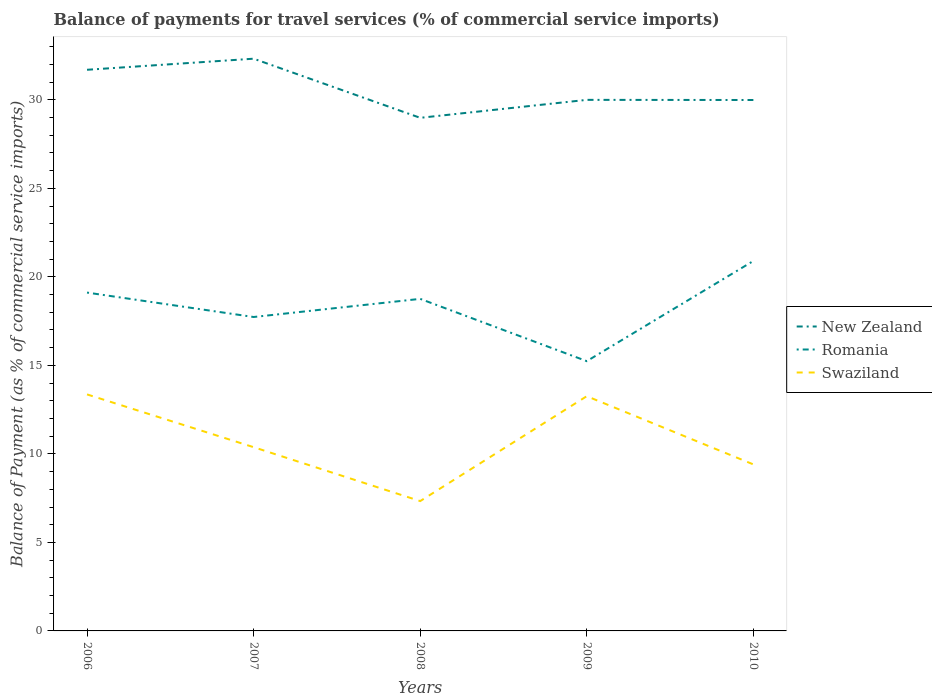How many different coloured lines are there?
Your answer should be very brief. 3. Does the line corresponding to Romania intersect with the line corresponding to Swaziland?
Offer a very short reply. No. Is the number of lines equal to the number of legend labels?
Keep it short and to the point. Yes. Across all years, what is the maximum balance of payments for travel services in Swaziland?
Provide a succinct answer. 7.34. What is the total balance of payments for travel services in Swaziland in the graph?
Offer a terse response. 3.04. What is the difference between the highest and the second highest balance of payments for travel services in New Zealand?
Provide a short and direct response. 3.34. What is the difference between the highest and the lowest balance of payments for travel services in Romania?
Your response must be concise. 3. Is the balance of payments for travel services in Swaziland strictly greater than the balance of payments for travel services in Romania over the years?
Your answer should be compact. Yes. How many lines are there?
Your answer should be very brief. 3. How many years are there in the graph?
Give a very brief answer. 5. Are the values on the major ticks of Y-axis written in scientific E-notation?
Offer a terse response. No. Does the graph contain any zero values?
Keep it short and to the point. No. Where does the legend appear in the graph?
Provide a short and direct response. Center right. What is the title of the graph?
Provide a short and direct response. Balance of payments for travel services (% of commercial service imports). What is the label or title of the X-axis?
Offer a very short reply. Years. What is the label or title of the Y-axis?
Your response must be concise. Balance of Payment (as % of commercial service imports). What is the Balance of Payment (as % of commercial service imports) in New Zealand in 2006?
Give a very brief answer. 31.7. What is the Balance of Payment (as % of commercial service imports) of Romania in 2006?
Keep it short and to the point. 19.11. What is the Balance of Payment (as % of commercial service imports) of Swaziland in 2006?
Offer a very short reply. 13.36. What is the Balance of Payment (as % of commercial service imports) in New Zealand in 2007?
Offer a very short reply. 32.33. What is the Balance of Payment (as % of commercial service imports) in Romania in 2007?
Provide a short and direct response. 17.73. What is the Balance of Payment (as % of commercial service imports) in Swaziland in 2007?
Offer a terse response. 10.38. What is the Balance of Payment (as % of commercial service imports) in New Zealand in 2008?
Provide a short and direct response. 28.99. What is the Balance of Payment (as % of commercial service imports) of Romania in 2008?
Your answer should be compact. 18.76. What is the Balance of Payment (as % of commercial service imports) of Swaziland in 2008?
Make the answer very short. 7.34. What is the Balance of Payment (as % of commercial service imports) of New Zealand in 2009?
Make the answer very short. 30. What is the Balance of Payment (as % of commercial service imports) of Romania in 2009?
Your answer should be very brief. 15.24. What is the Balance of Payment (as % of commercial service imports) of Swaziland in 2009?
Your answer should be compact. 13.26. What is the Balance of Payment (as % of commercial service imports) in New Zealand in 2010?
Make the answer very short. 29.99. What is the Balance of Payment (as % of commercial service imports) in Romania in 2010?
Provide a succinct answer. 20.9. What is the Balance of Payment (as % of commercial service imports) in Swaziland in 2010?
Your answer should be compact. 9.41. Across all years, what is the maximum Balance of Payment (as % of commercial service imports) in New Zealand?
Provide a succinct answer. 32.33. Across all years, what is the maximum Balance of Payment (as % of commercial service imports) of Romania?
Your response must be concise. 20.9. Across all years, what is the maximum Balance of Payment (as % of commercial service imports) of Swaziland?
Offer a terse response. 13.36. Across all years, what is the minimum Balance of Payment (as % of commercial service imports) in New Zealand?
Give a very brief answer. 28.99. Across all years, what is the minimum Balance of Payment (as % of commercial service imports) of Romania?
Provide a short and direct response. 15.24. Across all years, what is the minimum Balance of Payment (as % of commercial service imports) of Swaziland?
Give a very brief answer. 7.34. What is the total Balance of Payment (as % of commercial service imports) in New Zealand in the graph?
Provide a short and direct response. 153. What is the total Balance of Payment (as % of commercial service imports) in Romania in the graph?
Provide a succinct answer. 91.75. What is the total Balance of Payment (as % of commercial service imports) of Swaziland in the graph?
Make the answer very short. 53.74. What is the difference between the Balance of Payment (as % of commercial service imports) in New Zealand in 2006 and that in 2007?
Provide a succinct answer. -0.63. What is the difference between the Balance of Payment (as % of commercial service imports) in Romania in 2006 and that in 2007?
Your response must be concise. 1.38. What is the difference between the Balance of Payment (as % of commercial service imports) in Swaziland in 2006 and that in 2007?
Keep it short and to the point. 2.98. What is the difference between the Balance of Payment (as % of commercial service imports) in New Zealand in 2006 and that in 2008?
Offer a very short reply. 2.71. What is the difference between the Balance of Payment (as % of commercial service imports) of Romania in 2006 and that in 2008?
Offer a very short reply. 0.36. What is the difference between the Balance of Payment (as % of commercial service imports) of Swaziland in 2006 and that in 2008?
Give a very brief answer. 6.03. What is the difference between the Balance of Payment (as % of commercial service imports) of New Zealand in 2006 and that in 2009?
Give a very brief answer. 1.7. What is the difference between the Balance of Payment (as % of commercial service imports) of Romania in 2006 and that in 2009?
Offer a terse response. 3.87. What is the difference between the Balance of Payment (as % of commercial service imports) of Swaziland in 2006 and that in 2009?
Give a very brief answer. 0.1. What is the difference between the Balance of Payment (as % of commercial service imports) in New Zealand in 2006 and that in 2010?
Ensure brevity in your answer.  1.71. What is the difference between the Balance of Payment (as % of commercial service imports) of Romania in 2006 and that in 2010?
Ensure brevity in your answer.  -1.79. What is the difference between the Balance of Payment (as % of commercial service imports) in Swaziland in 2006 and that in 2010?
Make the answer very short. 3.95. What is the difference between the Balance of Payment (as % of commercial service imports) in New Zealand in 2007 and that in 2008?
Offer a terse response. 3.34. What is the difference between the Balance of Payment (as % of commercial service imports) in Romania in 2007 and that in 2008?
Make the answer very short. -1.02. What is the difference between the Balance of Payment (as % of commercial service imports) of Swaziland in 2007 and that in 2008?
Keep it short and to the point. 3.04. What is the difference between the Balance of Payment (as % of commercial service imports) in New Zealand in 2007 and that in 2009?
Make the answer very short. 2.33. What is the difference between the Balance of Payment (as % of commercial service imports) in Romania in 2007 and that in 2009?
Your answer should be compact. 2.49. What is the difference between the Balance of Payment (as % of commercial service imports) of Swaziland in 2007 and that in 2009?
Offer a terse response. -2.88. What is the difference between the Balance of Payment (as % of commercial service imports) of New Zealand in 2007 and that in 2010?
Offer a very short reply. 2.33. What is the difference between the Balance of Payment (as % of commercial service imports) in Romania in 2007 and that in 2010?
Your answer should be very brief. -3.17. What is the difference between the Balance of Payment (as % of commercial service imports) in Swaziland in 2007 and that in 2010?
Your response must be concise. 0.97. What is the difference between the Balance of Payment (as % of commercial service imports) of New Zealand in 2008 and that in 2009?
Make the answer very short. -1.01. What is the difference between the Balance of Payment (as % of commercial service imports) of Romania in 2008 and that in 2009?
Keep it short and to the point. 3.52. What is the difference between the Balance of Payment (as % of commercial service imports) of Swaziland in 2008 and that in 2009?
Your answer should be very brief. -5.92. What is the difference between the Balance of Payment (as % of commercial service imports) in New Zealand in 2008 and that in 2010?
Your answer should be compact. -1.01. What is the difference between the Balance of Payment (as % of commercial service imports) of Romania in 2008 and that in 2010?
Provide a short and direct response. -2.14. What is the difference between the Balance of Payment (as % of commercial service imports) of Swaziland in 2008 and that in 2010?
Provide a succinct answer. -2.07. What is the difference between the Balance of Payment (as % of commercial service imports) in New Zealand in 2009 and that in 2010?
Make the answer very short. 0.01. What is the difference between the Balance of Payment (as % of commercial service imports) of Romania in 2009 and that in 2010?
Make the answer very short. -5.66. What is the difference between the Balance of Payment (as % of commercial service imports) of Swaziland in 2009 and that in 2010?
Offer a very short reply. 3.85. What is the difference between the Balance of Payment (as % of commercial service imports) in New Zealand in 2006 and the Balance of Payment (as % of commercial service imports) in Romania in 2007?
Make the answer very short. 13.97. What is the difference between the Balance of Payment (as % of commercial service imports) in New Zealand in 2006 and the Balance of Payment (as % of commercial service imports) in Swaziland in 2007?
Your answer should be compact. 21.32. What is the difference between the Balance of Payment (as % of commercial service imports) of Romania in 2006 and the Balance of Payment (as % of commercial service imports) of Swaziland in 2007?
Provide a succinct answer. 8.73. What is the difference between the Balance of Payment (as % of commercial service imports) of New Zealand in 2006 and the Balance of Payment (as % of commercial service imports) of Romania in 2008?
Ensure brevity in your answer.  12.94. What is the difference between the Balance of Payment (as % of commercial service imports) of New Zealand in 2006 and the Balance of Payment (as % of commercial service imports) of Swaziland in 2008?
Offer a terse response. 24.36. What is the difference between the Balance of Payment (as % of commercial service imports) of Romania in 2006 and the Balance of Payment (as % of commercial service imports) of Swaziland in 2008?
Your answer should be compact. 11.78. What is the difference between the Balance of Payment (as % of commercial service imports) in New Zealand in 2006 and the Balance of Payment (as % of commercial service imports) in Romania in 2009?
Your response must be concise. 16.46. What is the difference between the Balance of Payment (as % of commercial service imports) of New Zealand in 2006 and the Balance of Payment (as % of commercial service imports) of Swaziland in 2009?
Offer a very short reply. 18.44. What is the difference between the Balance of Payment (as % of commercial service imports) in Romania in 2006 and the Balance of Payment (as % of commercial service imports) in Swaziland in 2009?
Offer a terse response. 5.85. What is the difference between the Balance of Payment (as % of commercial service imports) in New Zealand in 2006 and the Balance of Payment (as % of commercial service imports) in Romania in 2010?
Your response must be concise. 10.8. What is the difference between the Balance of Payment (as % of commercial service imports) in New Zealand in 2006 and the Balance of Payment (as % of commercial service imports) in Swaziland in 2010?
Your answer should be very brief. 22.29. What is the difference between the Balance of Payment (as % of commercial service imports) in Romania in 2006 and the Balance of Payment (as % of commercial service imports) in Swaziland in 2010?
Provide a short and direct response. 9.71. What is the difference between the Balance of Payment (as % of commercial service imports) of New Zealand in 2007 and the Balance of Payment (as % of commercial service imports) of Romania in 2008?
Give a very brief answer. 13.57. What is the difference between the Balance of Payment (as % of commercial service imports) of New Zealand in 2007 and the Balance of Payment (as % of commercial service imports) of Swaziland in 2008?
Keep it short and to the point. 24.99. What is the difference between the Balance of Payment (as % of commercial service imports) of Romania in 2007 and the Balance of Payment (as % of commercial service imports) of Swaziland in 2008?
Your answer should be very brief. 10.4. What is the difference between the Balance of Payment (as % of commercial service imports) of New Zealand in 2007 and the Balance of Payment (as % of commercial service imports) of Romania in 2009?
Offer a very short reply. 17.09. What is the difference between the Balance of Payment (as % of commercial service imports) of New Zealand in 2007 and the Balance of Payment (as % of commercial service imports) of Swaziland in 2009?
Provide a succinct answer. 19.07. What is the difference between the Balance of Payment (as % of commercial service imports) of Romania in 2007 and the Balance of Payment (as % of commercial service imports) of Swaziland in 2009?
Make the answer very short. 4.47. What is the difference between the Balance of Payment (as % of commercial service imports) in New Zealand in 2007 and the Balance of Payment (as % of commercial service imports) in Romania in 2010?
Provide a succinct answer. 11.43. What is the difference between the Balance of Payment (as % of commercial service imports) in New Zealand in 2007 and the Balance of Payment (as % of commercial service imports) in Swaziland in 2010?
Your response must be concise. 22.92. What is the difference between the Balance of Payment (as % of commercial service imports) in Romania in 2007 and the Balance of Payment (as % of commercial service imports) in Swaziland in 2010?
Make the answer very short. 8.33. What is the difference between the Balance of Payment (as % of commercial service imports) in New Zealand in 2008 and the Balance of Payment (as % of commercial service imports) in Romania in 2009?
Your answer should be compact. 13.75. What is the difference between the Balance of Payment (as % of commercial service imports) of New Zealand in 2008 and the Balance of Payment (as % of commercial service imports) of Swaziland in 2009?
Give a very brief answer. 15.73. What is the difference between the Balance of Payment (as % of commercial service imports) in Romania in 2008 and the Balance of Payment (as % of commercial service imports) in Swaziland in 2009?
Your answer should be compact. 5.5. What is the difference between the Balance of Payment (as % of commercial service imports) of New Zealand in 2008 and the Balance of Payment (as % of commercial service imports) of Romania in 2010?
Your answer should be very brief. 8.09. What is the difference between the Balance of Payment (as % of commercial service imports) in New Zealand in 2008 and the Balance of Payment (as % of commercial service imports) in Swaziland in 2010?
Your answer should be very brief. 19.58. What is the difference between the Balance of Payment (as % of commercial service imports) in Romania in 2008 and the Balance of Payment (as % of commercial service imports) in Swaziland in 2010?
Offer a terse response. 9.35. What is the difference between the Balance of Payment (as % of commercial service imports) in New Zealand in 2009 and the Balance of Payment (as % of commercial service imports) in Romania in 2010?
Make the answer very short. 9.1. What is the difference between the Balance of Payment (as % of commercial service imports) of New Zealand in 2009 and the Balance of Payment (as % of commercial service imports) of Swaziland in 2010?
Give a very brief answer. 20.59. What is the difference between the Balance of Payment (as % of commercial service imports) in Romania in 2009 and the Balance of Payment (as % of commercial service imports) in Swaziland in 2010?
Your answer should be compact. 5.83. What is the average Balance of Payment (as % of commercial service imports) of New Zealand per year?
Make the answer very short. 30.6. What is the average Balance of Payment (as % of commercial service imports) in Romania per year?
Offer a very short reply. 18.35. What is the average Balance of Payment (as % of commercial service imports) in Swaziland per year?
Your answer should be compact. 10.75. In the year 2006, what is the difference between the Balance of Payment (as % of commercial service imports) in New Zealand and Balance of Payment (as % of commercial service imports) in Romania?
Give a very brief answer. 12.59. In the year 2006, what is the difference between the Balance of Payment (as % of commercial service imports) in New Zealand and Balance of Payment (as % of commercial service imports) in Swaziland?
Your answer should be compact. 18.34. In the year 2006, what is the difference between the Balance of Payment (as % of commercial service imports) in Romania and Balance of Payment (as % of commercial service imports) in Swaziland?
Your answer should be compact. 5.75. In the year 2007, what is the difference between the Balance of Payment (as % of commercial service imports) of New Zealand and Balance of Payment (as % of commercial service imports) of Romania?
Provide a succinct answer. 14.59. In the year 2007, what is the difference between the Balance of Payment (as % of commercial service imports) of New Zealand and Balance of Payment (as % of commercial service imports) of Swaziland?
Give a very brief answer. 21.95. In the year 2007, what is the difference between the Balance of Payment (as % of commercial service imports) in Romania and Balance of Payment (as % of commercial service imports) in Swaziland?
Your answer should be compact. 7.35. In the year 2008, what is the difference between the Balance of Payment (as % of commercial service imports) of New Zealand and Balance of Payment (as % of commercial service imports) of Romania?
Your response must be concise. 10.23. In the year 2008, what is the difference between the Balance of Payment (as % of commercial service imports) of New Zealand and Balance of Payment (as % of commercial service imports) of Swaziland?
Offer a very short reply. 21.65. In the year 2008, what is the difference between the Balance of Payment (as % of commercial service imports) in Romania and Balance of Payment (as % of commercial service imports) in Swaziland?
Your answer should be compact. 11.42. In the year 2009, what is the difference between the Balance of Payment (as % of commercial service imports) of New Zealand and Balance of Payment (as % of commercial service imports) of Romania?
Ensure brevity in your answer.  14.76. In the year 2009, what is the difference between the Balance of Payment (as % of commercial service imports) in New Zealand and Balance of Payment (as % of commercial service imports) in Swaziland?
Your response must be concise. 16.74. In the year 2009, what is the difference between the Balance of Payment (as % of commercial service imports) in Romania and Balance of Payment (as % of commercial service imports) in Swaziland?
Offer a very short reply. 1.98. In the year 2010, what is the difference between the Balance of Payment (as % of commercial service imports) in New Zealand and Balance of Payment (as % of commercial service imports) in Romania?
Provide a short and direct response. 9.09. In the year 2010, what is the difference between the Balance of Payment (as % of commercial service imports) of New Zealand and Balance of Payment (as % of commercial service imports) of Swaziland?
Provide a short and direct response. 20.59. In the year 2010, what is the difference between the Balance of Payment (as % of commercial service imports) of Romania and Balance of Payment (as % of commercial service imports) of Swaziland?
Offer a very short reply. 11.49. What is the ratio of the Balance of Payment (as % of commercial service imports) of New Zealand in 2006 to that in 2007?
Provide a short and direct response. 0.98. What is the ratio of the Balance of Payment (as % of commercial service imports) in Romania in 2006 to that in 2007?
Ensure brevity in your answer.  1.08. What is the ratio of the Balance of Payment (as % of commercial service imports) of Swaziland in 2006 to that in 2007?
Offer a terse response. 1.29. What is the ratio of the Balance of Payment (as % of commercial service imports) of New Zealand in 2006 to that in 2008?
Your answer should be very brief. 1.09. What is the ratio of the Balance of Payment (as % of commercial service imports) of Romania in 2006 to that in 2008?
Offer a terse response. 1.02. What is the ratio of the Balance of Payment (as % of commercial service imports) in Swaziland in 2006 to that in 2008?
Provide a succinct answer. 1.82. What is the ratio of the Balance of Payment (as % of commercial service imports) in New Zealand in 2006 to that in 2009?
Offer a terse response. 1.06. What is the ratio of the Balance of Payment (as % of commercial service imports) of Romania in 2006 to that in 2009?
Offer a terse response. 1.25. What is the ratio of the Balance of Payment (as % of commercial service imports) of Swaziland in 2006 to that in 2009?
Provide a succinct answer. 1.01. What is the ratio of the Balance of Payment (as % of commercial service imports) of New Zealand in 2006 to that in 2010?
Your answer should be compact. 1.06. What is the ratio of the Balance of Payment (as % of commercial service imports) of Romania in 2006 to that in 2010?
Your answer should be very brief. 0.91. What is the ratio of the Balance of Payment (as % of commercial service imports) in Swaziland in 2006 to that in 2010?
Your answer should be compact. 1.42. What is the ratio of the Balance of Payment (as % of commercial service imports) of New Zealand in 2007 to that in 2008?
Offer a very short reply. 1.12. What is the ratio of the Balance of Payment (as % of commercial service imports) of Romania in 2007 to that in 2008?
Offer a very short reply. 0.95. What is the ratio of the Balance of Payment (as % of commercial service imports) in Swaziland in 2007 to that in 2008?
Your response must be concise. 1.42. What is the ratio of the Balance of Payment (as % of commercial service imports) of New Zealand in 2007 to that in 2009?
Provide a short and direct response. 1.08. What is the ratio of the Balance of Payment (as % of commercial service imports) of Romania in 2007 to that in 2009?
Your response must be concise. 1.16. What is the ratio of the Balance of Payment (as % of commercial service imports) of Swaziland in 2007 to that in 2009?
Provide a succinct answer. 0.78. What is the ratio of the Balance of Payment (as % of commercial service imports) of New Zealand in 2007 to that in 2010?
Provide a short and direct response. 1.08. What is the ratio of the Balance of Payment (as % of commercial service imports) of Romania in 2007 to that in 2010?
Ensure brevity in your answer.  0.85. What is the ratio of the Balance of Payment (as % of commercial service imports) in Swaziland in 2007 to that in 2010?
Offer a terse response. 1.1. What is the ratio of the Balance of Payment (as % of commercial service imports) of New Zealand in 2008 to that in 2009?
Ensure brevity in your answer.  0.97. What is the ratio of the Balance of Payment (as % of commercial service imports) of Romania in 2008 to that in 2009?
Give a very brief answer. 1.23. What is the ratio of the Balance of Payment (as % of commercial service imports) in Swaziland in 2008 to that in 2009?
Offer a terse response. 0.55. What is the ratio of the Balance of Payment (as % of commercial service imports) of New Zealand in 2008 to that in 2010?
Provide a succinct answer. 0.97. What is the ratio of the Balance of Payment (as % of commercial service imports) of Romania in 2008 to that in 2010?
Offer a very short reply. 0.9. What is the ratio of the Balance of Payment (as % of commercial service imports) of Swaziland in 2008 to that in 2010?
Ensure brevity in your answer.  0.78. What is the ratio of the Balance of Payment (as % of commercial service imports) of New Zealand in 2009 to that in 2010?
Ensure brevity in your answer.  1. What is the ratio of the Balance of Payment (as % of commercial service imports) in Romania in 2009 to that in 2010?
Keep it short and to the point. 0.73. What is the ratio of the Balance of Payment (as % of commercial service imports) of Swaziland in 2009 to that in 2010?
Give a very brief answer. 1.41. What is the difference between the highest and the second highest Balance of Payment (as % of commercial service imports) of New Zealand?
Make the answer very short. 0.63. What is the difference between the highest and the second highest Balance of Payment (as % of commercial service imports) in Romania?
Provide a short and direct response. 1.79. What is the difference between the highest and the second highest Balance of Payment (as % of commercial service imports) of Swaziland?
Provide a short and direct response. 0.1. What is the difference between the highest and the lowest Balance of Payment (as % of commercial service imports) in New Zealand?
Provide a succinct answer. 3.34. What is the difference between the highest and the lowest Balance of Payment (as % of commercial service imports) of Romania?
Ensure brevity in your answer.  5.66. What is the difference between the highest and the lowest Balance of Payment (as % of commercial service imports) in Swaziland?
Keep it short and to the point. 6.03. 